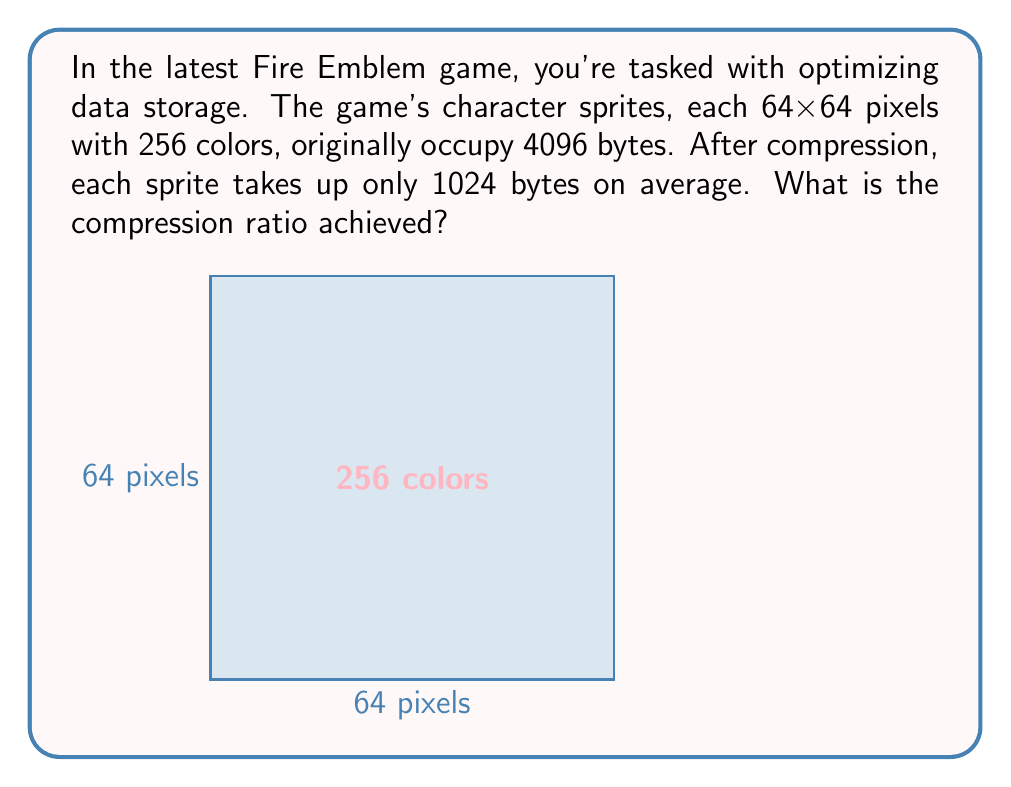Show me your answer to this math problem. Let's approach this step-by-step:

1) First, let's calculate the original file size in bits:
   - Each pixel can have 256 colors, which requires 8 bits (2^8 = 256)
   - The sprite is 64x64 pixels
   - Total bits = $64 \times 64 \times 8 = 32768$ bits

2) Convert bits to bytes:
   - $32768 \text{ bits} \div 8 = 4096$ bytes

3) The compressed size is given as 1024 bytes

4) The compression ratio is calculated as:
   $$ \text{Compression Ratio} = \frac{\text{Uncompressed Size}}{\text{Compressed Size}} $$

5) Plugging in our values:
   $$ \text{Compression Ratio} = \frac{4096 \text{ bytes}}{1024 \text{ bytes}} = 4 $$

This means the original data has been compressed to 1/4 of its original size.
Answer: 4:1 